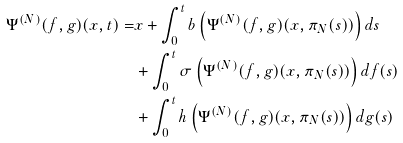<formula> <loc_0><loc_0><loc_500><loc_500>\Psi ^ { ( N ) } ( f , g ) ( x , t ) = & x + \int _ { 0 } ^ { t } b \left ( \Psi ^ { ( N ) } ( f , g ) ( x , \pi _ { N } ( s ) ) \right ) d s \\ & + \int _ { 0 } ^ { t } \sigma \left ( \Psi ^ { ( N ) } ( f , g ) ( x , \pi _ { N } ( s ) ) \right ) d f ( s ) \\ & + \int _ { 0 } ^ { t } h \left ( \Psi ^ { ( N ) } ( f , g ) ( x , \pi _ { N } ( s ) ) \right ) d g ( s )</formula> 